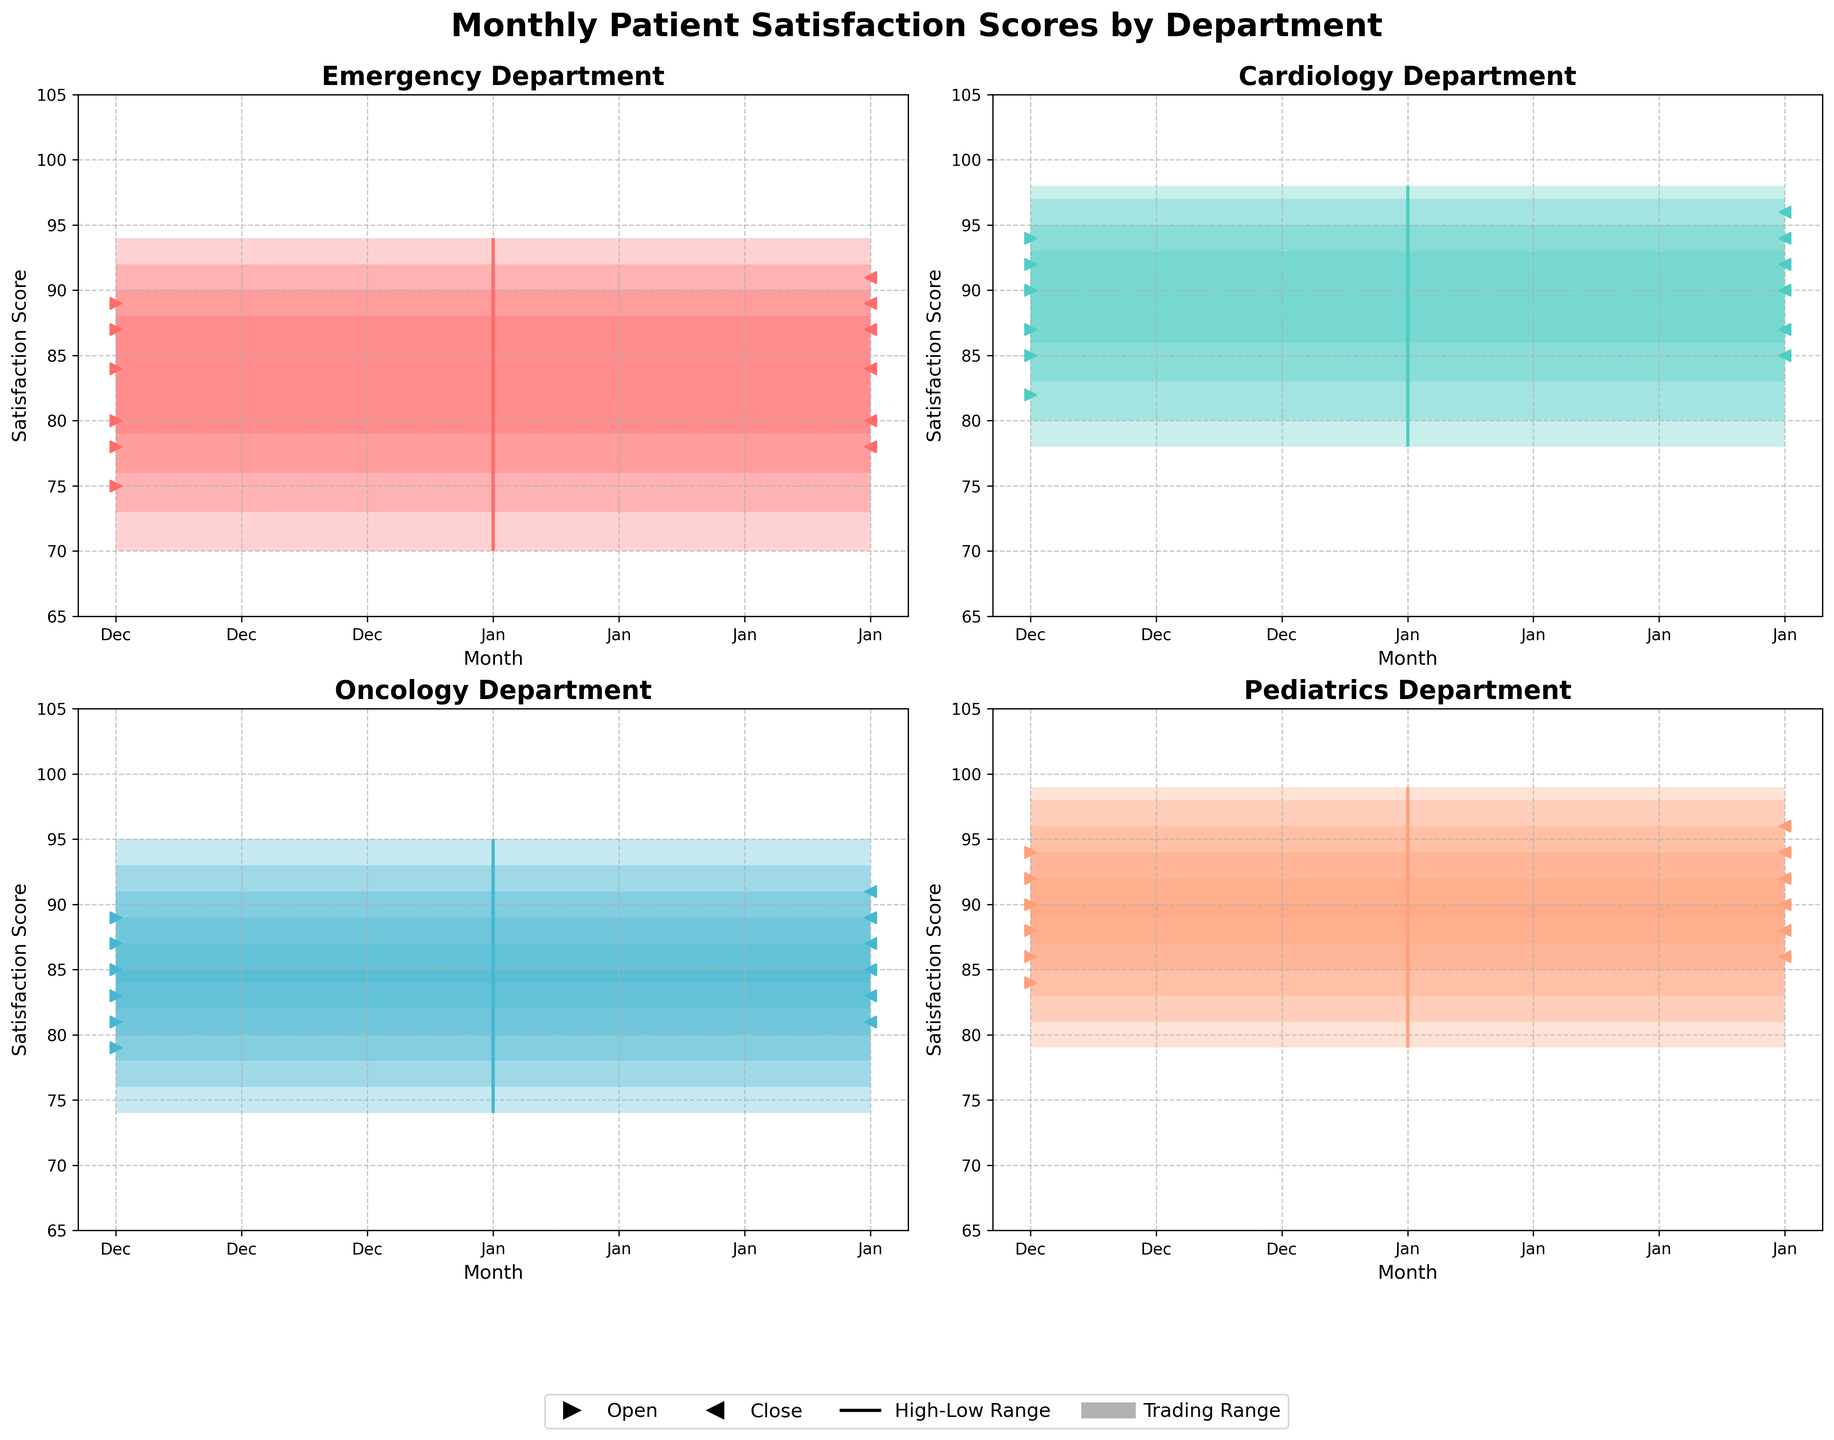What's the title of the figure? The title of the figure is displayed at the top of the chart.
Answer: Monthly Patient Satisfaction Scores by Department How many departments' data are presented in the figure? Each subplot title represents a different department. There are four subplots.
Answer: Four Which month has the highest patient satisfaction score for the Emergency Department? Find the highest point in the Emergency subplot. The highest high is in June, with a score of 94.
Answer: June What is the general trend of patient satisfaction scores in the Cardiology Department from January to June? Observe the successive "Highs" and "Closes" in the Cardiology subplot. Both are increasing steadily from January to June.
Answer: Increasing In which department does the patient satisfaction score show the smallest monthly variation in June? Compare the vertical range (difference between high and low values) in June for all departments. The Emergency Department has the smallest range (94-85 = 9).
Answer: Emergency Which department has the most significant improvement in patient satisfaction scores between January and June? Compare the "Open" values of January and June for each department and calculate the difference. Cardiology shows the highest improvement (94 - 82 = 12).
Answer: Cardiology Which department had the highest closing score in May? Look at the "Close" value for May in each subplot. Pediatrics has the highest closing score of 94.
Answer: Pediatrics How does the variability of satisfaction scores in Oncology compare to that in Cardiology in April? Compare the vertical range for both departments in April. Oncology has a range of 91-80=11, while Cardiology has a range of 95-86=9.
Answer: More variable What can be inferred about patient satisfaction trends in the Pediatrics Department during the first half of the year? Observe the "Highs," "Lows," "Opens," and "Closes" from January to June. All values consistently rise, indicating an improvement trend.
Answer: Improvement trend 